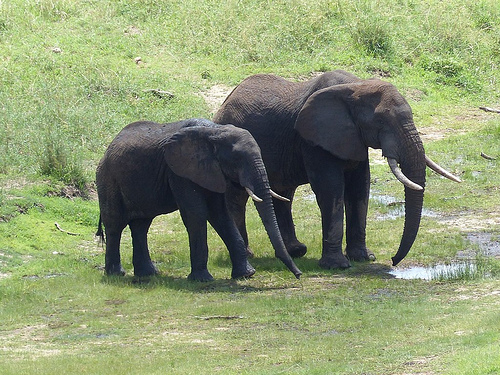Are there soap dispensers or electric toothbrushes? No, there are no soap dispensers or electric toothbrushes visible in this image. 